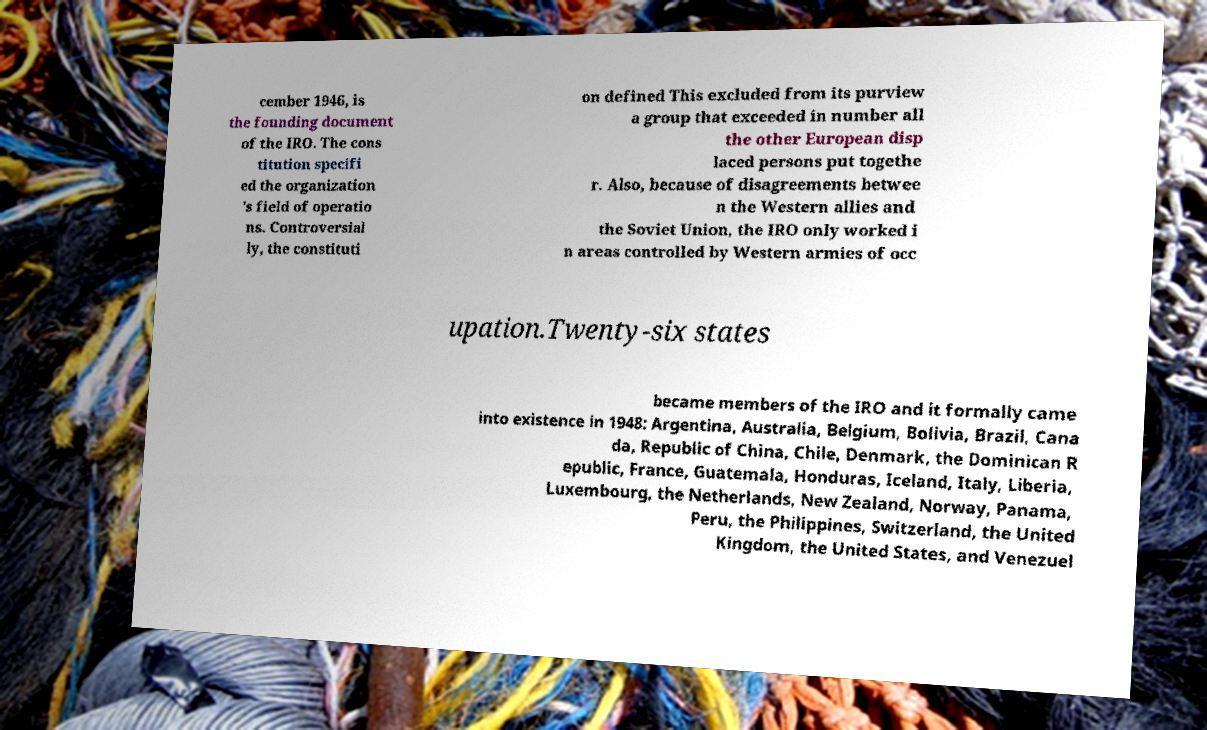I need the written content from this picture converted into text. Can you do that? cember 1946, is the founding document of the IRO. The cons titution specifi ed the organization 's field of operatio ns. Controversial ly, the constituti on defined This excluded from its purview a group that exceeded in number all the other European disp laced persons put togethe r. Also, because of disagreements betwee n the Western allies and the Soviet Union, the IRO only worked i n areas controlled by Western armies of occ upation.Twenty-six states became members of the IRO and it formally came into existence in 1948: Argentina, Australia, Belgium, Bolivia, Brazil, Cana da, Republic of China, Chile, Denmark, the Dominican R epublic, France, Guatemala, Honduras, Iceland, Italy, Liberia, Luxembourg, the Netherlands, New Zealand, Norway, Panama, Peru, the Philippines, Switzerland, the United Kingdom, the United States, and Venezuel 